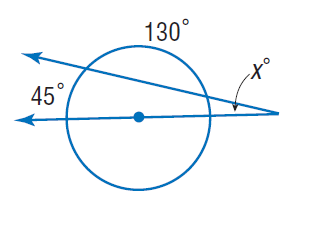Question: Find x.
Choices:
A. 20
B. 45
C. 65
D. 130
Answer with the letter. Answer: A 